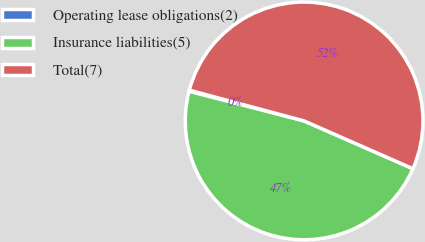Convert chart to OTSL. <chart><loc_0><loc_0><loc_500><loc_500><pie_chart><fcel>Operating lease obligations(2)<fcel>Insurance liabilities(5)<fcel>Total(7)<nl><fcel>0.16%<fcel>47.42%<fcel>52.42%<nl></chart> 